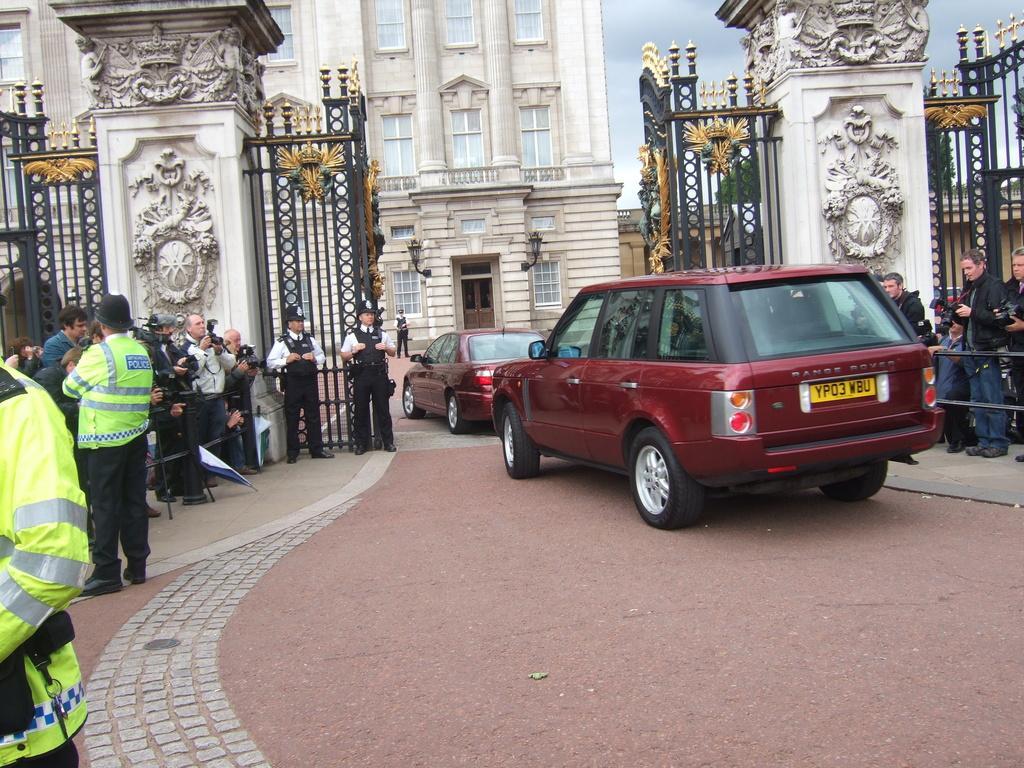In one or two sentences, can you explain what this image depicts? In this picture we can see vehicles and people on the ground and in the background we can see a building and the sky. 